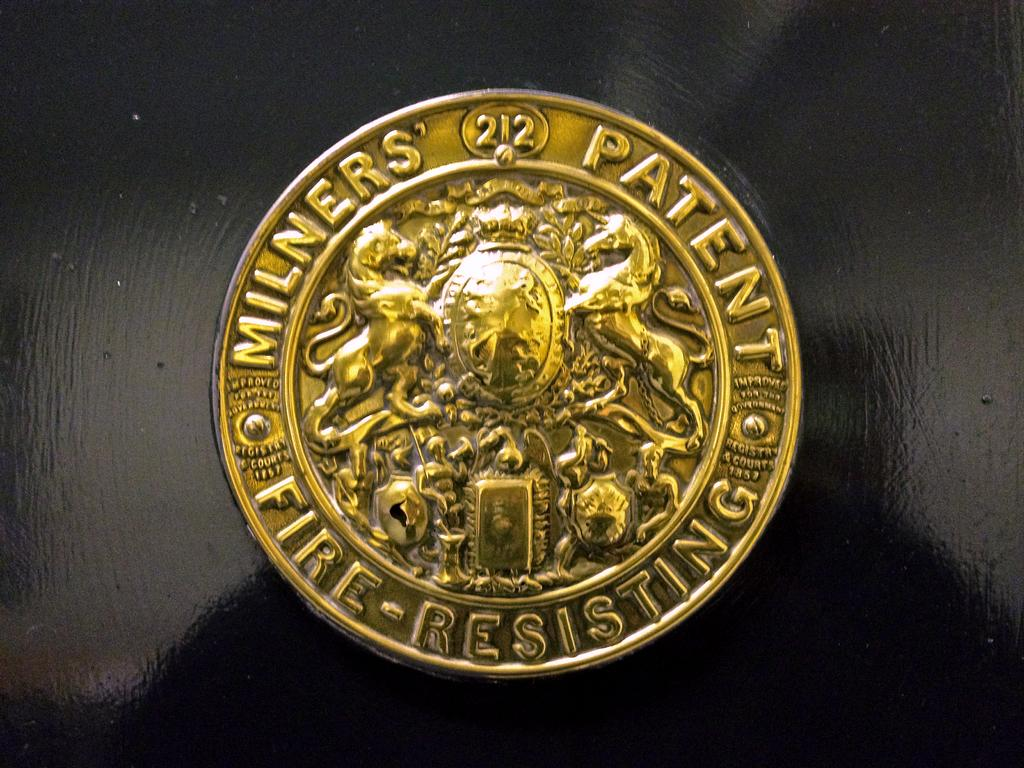<image>
Provide a brief description of the given image. A gold Milners' Patent Fire-Resisting coin with a lion and a unicorn on it. 